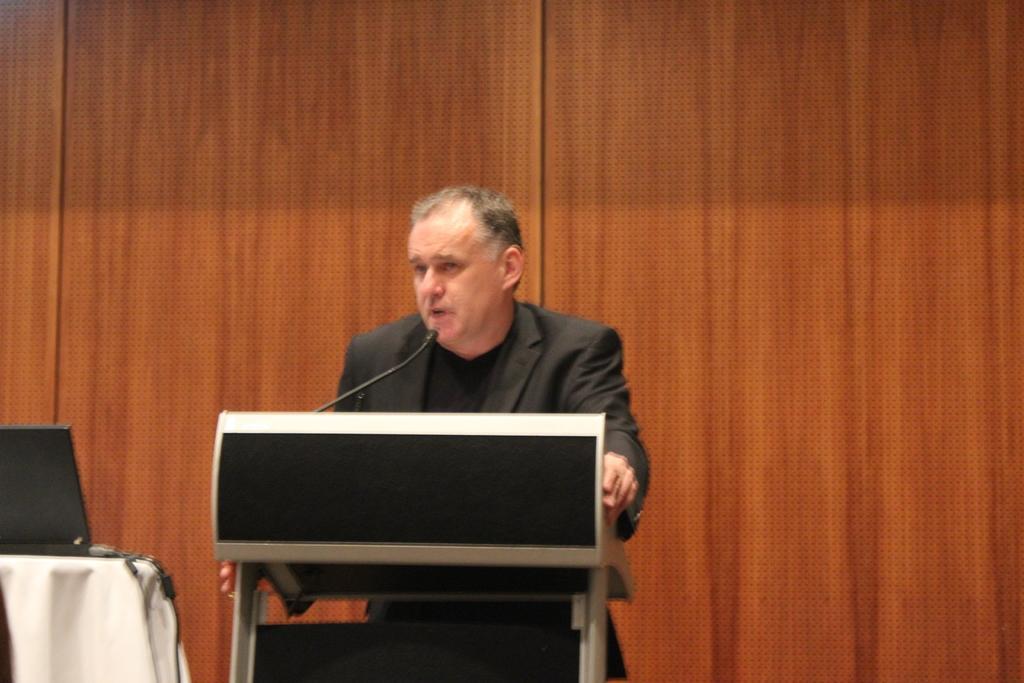Please provide a concise description of this image. In this image there is a man standing near the podium and speaking in the mic. In the background there is a wooden wall. On the left side there is a table on which there is a laptop with the wires. 